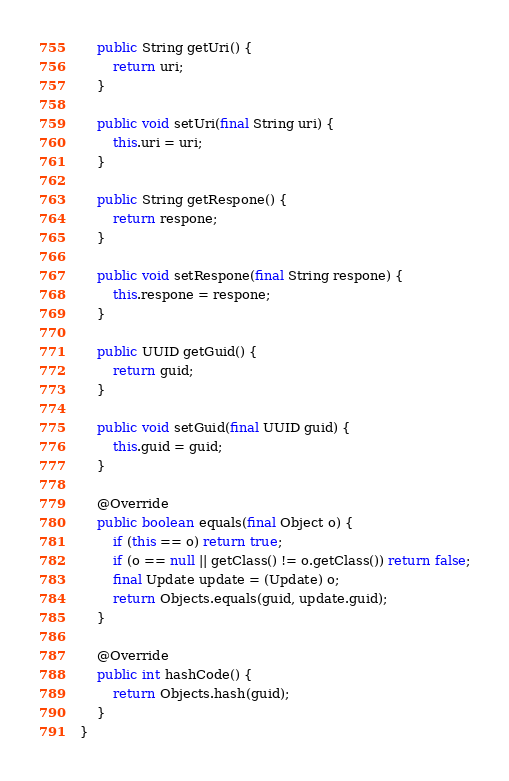<code> <loc_0><loc_0><loc_500><loc_500><_Java_>
    public String getUri() {
        return uri;
    }

    public void setUri(final String uri) {
        this.uri = uri;
    }

    public String getRespone() {
        return respone;
    }

    public void setRespone(final String respone) {
        this.respone = respone;
    }

    public UUID getGuid() {
        return guid;
    }

    public void setGuid(final UUID guid) {
        this.guid = guid;
    }

    @Override
    public boolean equals(final Object o) {
        if (this == o) return true;
        if (o == null || getClass() != o.getClass()) return false;
        final Update update = (Update) o;
        return Objects.equals(guid, update.guid);
    }

    @Override
    public int hashCode() {
        return Objects.hash(guid);
    }
}
</code> 